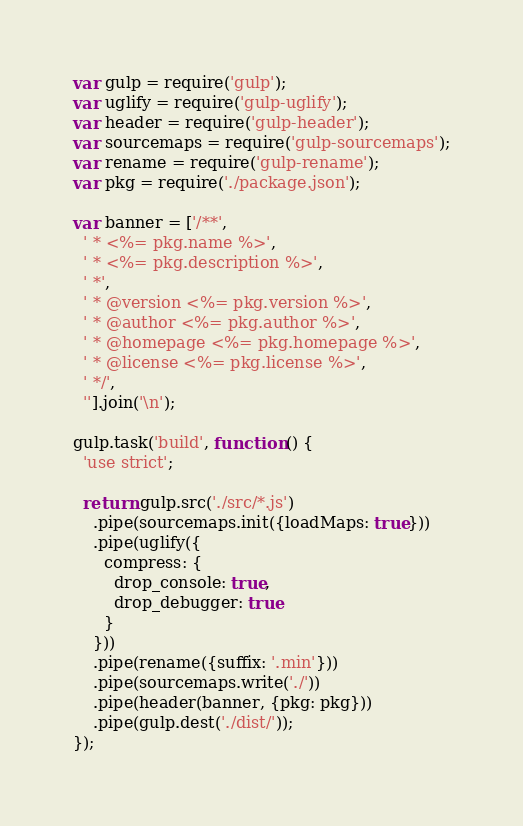<code> <loc_0><loc_0><loc_500><loc_500><_JavaScript_>var gulp = require('gulp');
var uglify = require('gulp-uglify');
var header = require('gulp-header');
var sourcemaps = require('gulp-sourcemaps');
var rename = require('gulp-rename');
var pkg = require('./package.json');

var banner = ['/**',
  ' * <%= pkg.name %>',
  ' * <%= pkg.description %>',
  ' *',
  ' * @version <%= pkg.version %>',
  ' * @author <%= pkg.author %>',
  ' * @homepage <%= pkg.homepage %>',
  ' * @license <%= pkg.license %>',
  ' */',
  ''].join('\n');

gulp.task('build', function () {
  'use strict';

  return gulp.src('./src/*.js')
    .pipe(sourcemaps.init({loadMaps: true}))
    .pipe(uglify({
      compress: {
        drop_console: true,
        drop_debugger: true
      }
    }))
    .pipe(rename({suffix: '.min'}))
    .pipe(sourcemaps.write('./'))
    .pipe(header(banner, {pkg: pkg}))
    .pipe(gulp.dest('./dist/'));
});
</code> 